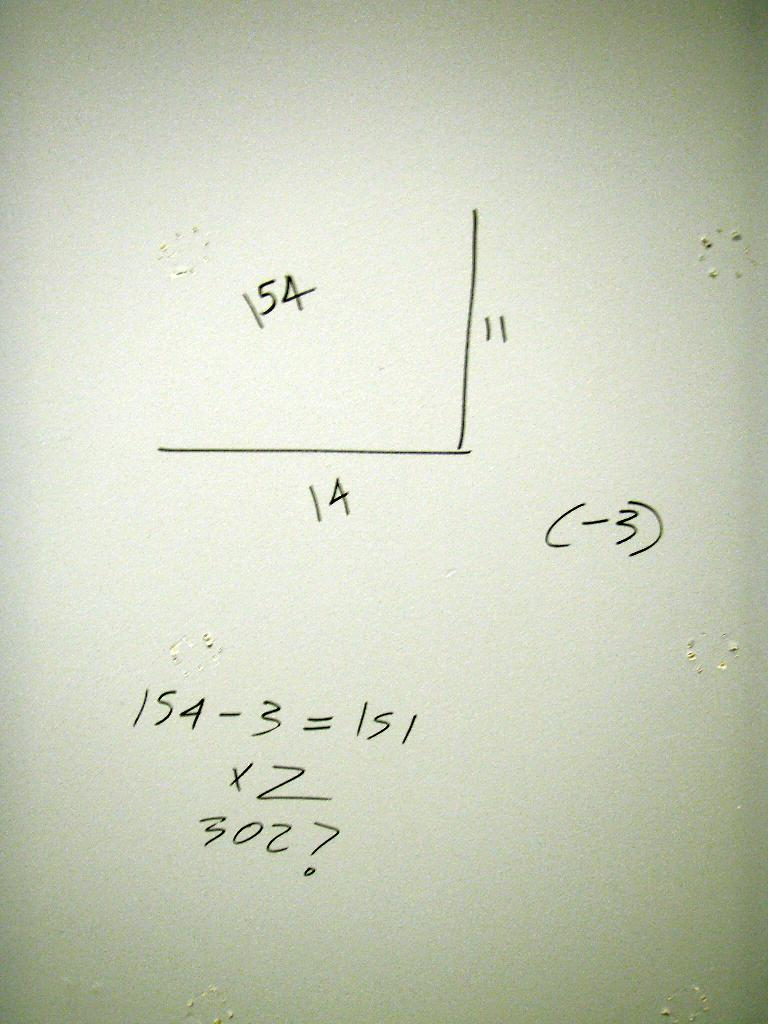Provide a one-sentence caption for the provided image. A math problem is shown with one of the equations being 154-3. 